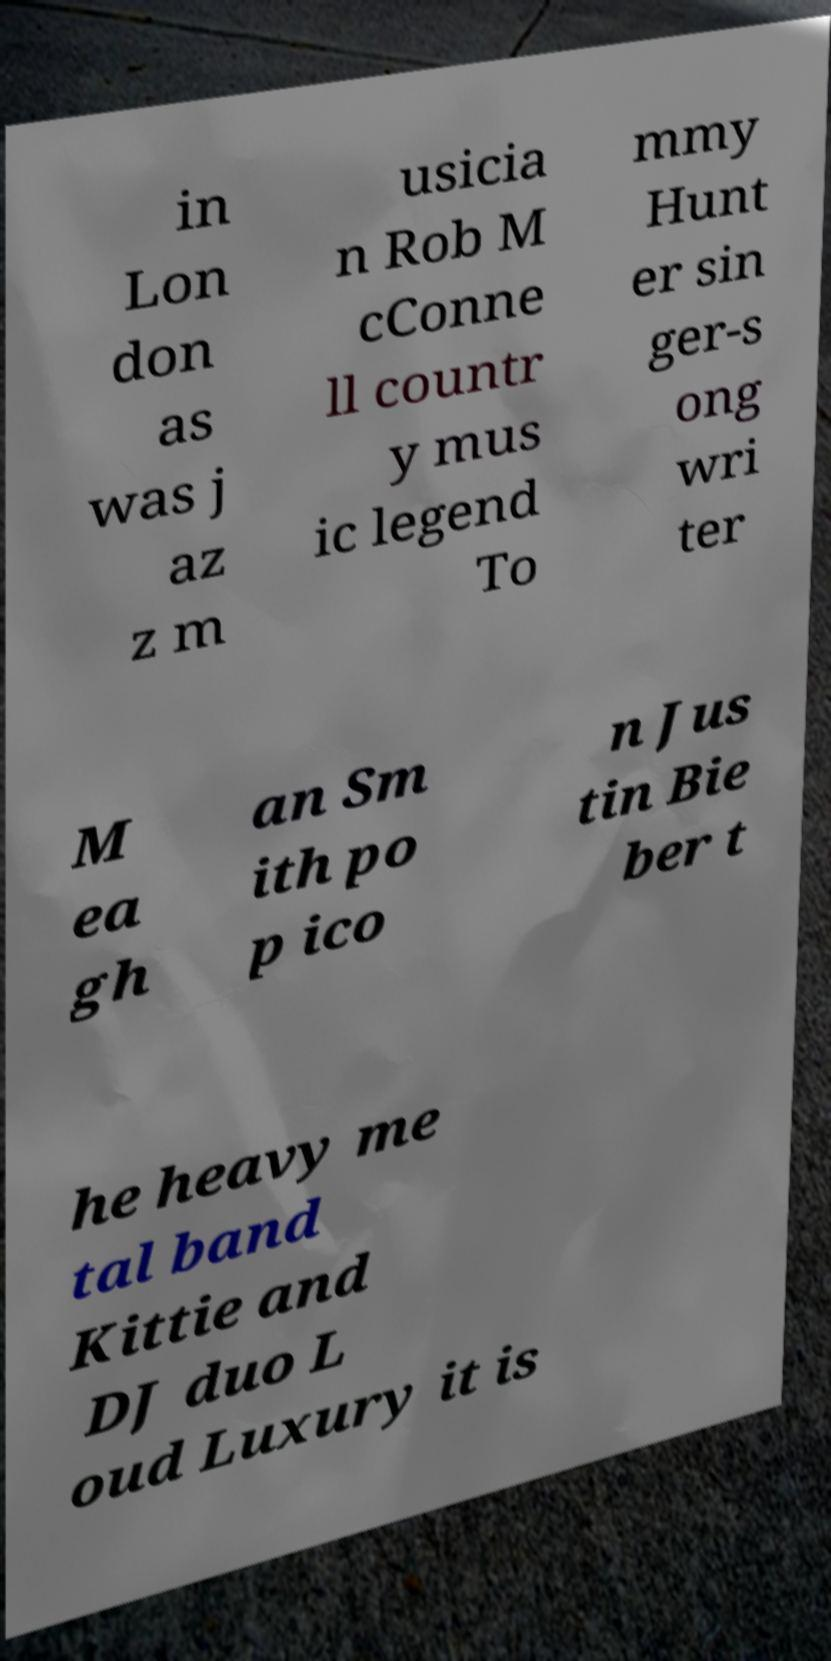Please read and relay the text visible in this image. What does it say? in Lon don as was j az z m usicia n Rob M cConne ll countr y mus ic legend To mmy Hunt er sin ger-s ong wri ter M ea gh an Sm ith po p ico n Jus tin Bie ber t he heavy me tal band Kittie and DJ duo L oud Luxury it is 